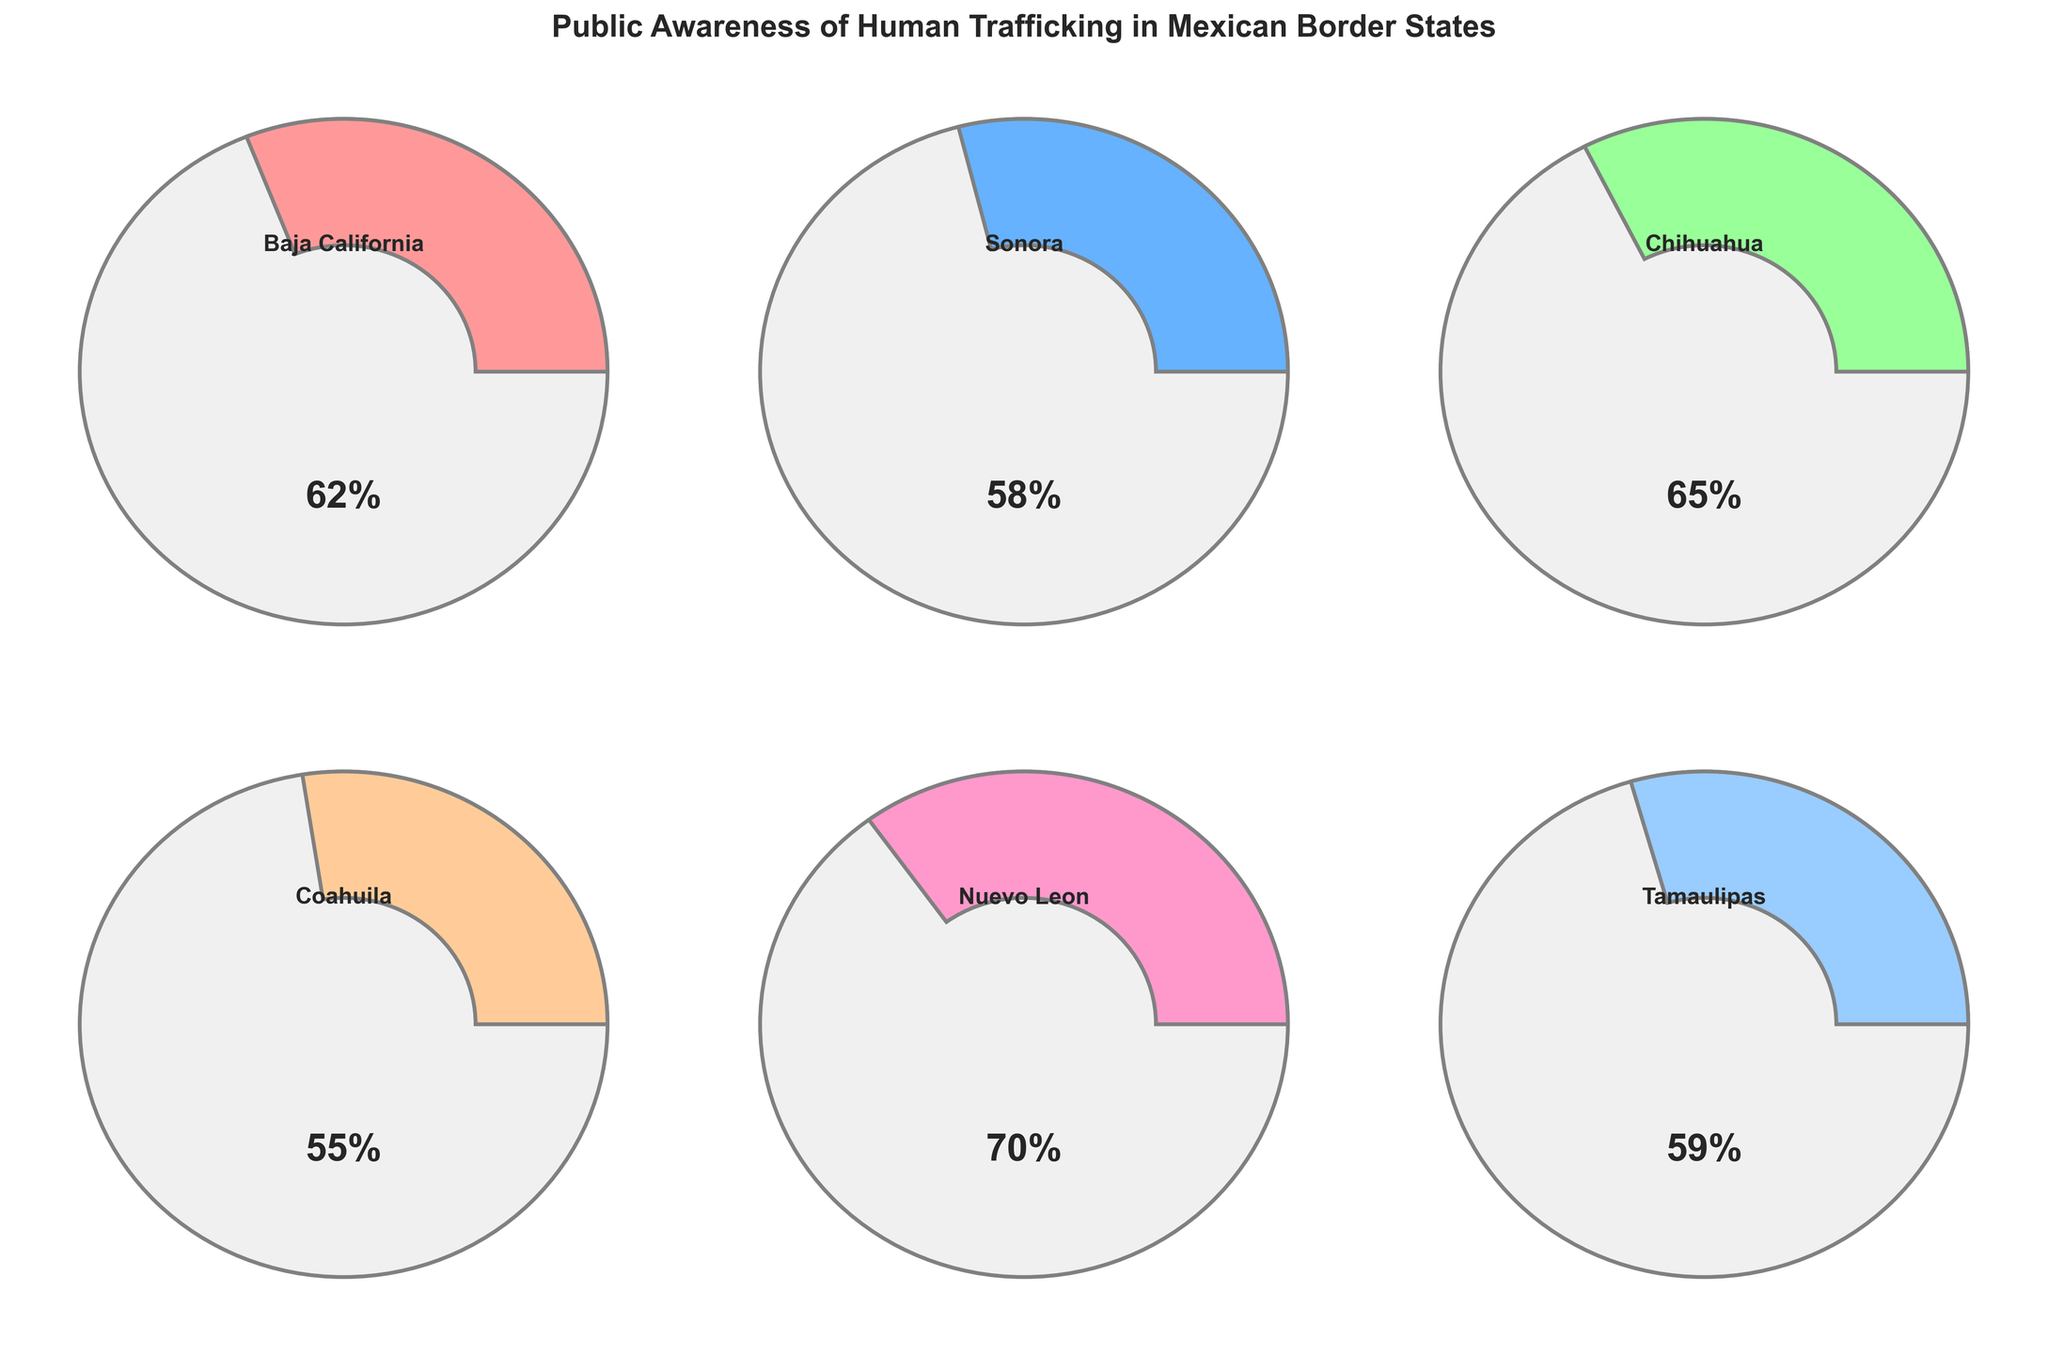Which state has the highest public awareness level of human trafficking? By referring to the gauge charts, we observe the awareness levels for each state. The gauge for Nuevo Leon shows the highest value at 70%.
Answer: Nuevo Leon Which state has the lowest public awareness level of human trafficking? By referring to the gauge charts, we observe the awareness levels for each state. The gauge for Coahuila shows the lowest value at 55%.
Answer: Coahuila What is the average awareness level across all the states? Sum the awareness levels for all the states and then divide by the number of states: (62 + 58 + 65 + 55 + 70 + 59) / 6 = 369 / 6 = 61.5
Answer: 61.5 Which state has a greater awareness level, Chihuahua or Tamaulipas? Compare the gauges for Chihuahua and Tamaulipas. Chihuahua has an awareness level of 65%, whereas Tamaulipas has 59%.
Answer: Chihuahua How much higher is Baja California's awareness level compared to Sonora's? Subtract Sonora's awareness level from Baja California's: 62% - 58% = 4%
Answer: 4% What is the total awareness level for Nuevo Leon and Sonora combined? Add the awareness levels of Nuevo Leon and Sonora: 70% + 58% = 128%
Answer: 128% Which states have an awareness level of 60% or higher? Identify all states with awareness levels of 60% or higher. These states are Baja California (62%), Chihuahua (65%), and Nuevo Leon (70%).
Answer: Baja California, Chihuahua, Nuevo Leon What is the median awareness level among the Mexican border states listed? First, order the awareness levels: 55, 58, 59, 62, 65, 70. The median is the average of the two middle numbers: (59 + 62) / 2 = 60.5.
Answer: 60.5 Which color is used for the gauge representing Tamaulipas? By referring to the color legend in the plot, Tamaulipas' gauge is shown in pink.
Answer: Pink 